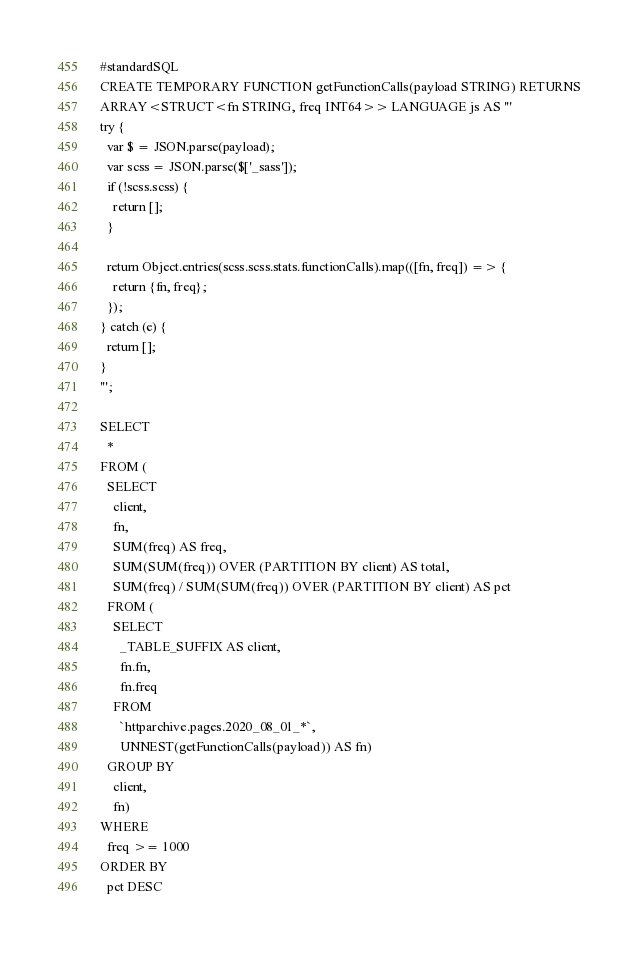Convert code to text. <code><loc_0><loc_0><loc_500><loc_500><_SQL_>#standardSQL
CREATE TEMPORARY FUNCTION getFunctionCalls(payload STRING) RETURNS
ARRAY<STRUCT<fn STRING, freq INT64>> LANGUAGE js AS '''
try {
  var $ = JSON.parse(payload);
  var scss = JSON.parse($['_sass']);
  if (!scss.scss) {
    return [];
  }

  return Object.entries(scss.scss.stats.functionCalls).map(([fn, freq]) => {
    return {fn, freq};
  });
} catch (e) {
  return [];
}
''';

SELECT
  *
FROM (
  SELECT
    client,
    fn,
    SUM(freq) AS freq,
    SUM(SUM(freq)) OVER (PARTITION BY client) AS total,
    SUM(freq) / SUM(SUM(freq)) OVER (PARTITION BY client) AS pct
  FROM (
    SELECT
      _TABLE_SUFFIX AS client,
      fn.fn,
      fn.freq
    FROM
      `httparchive.pages.2020_08_01_*`,
      UNNEST(getFunctionCalls(payload)) AS fn)
  GROUP BY
    client,
    fn)
WHERE
  freq >= 1000
ORDER BY
  pct DESC
</code> 